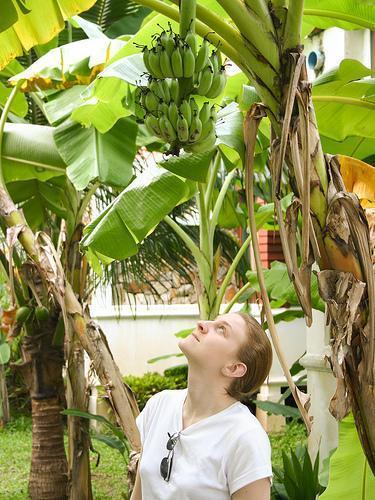How many people are there?
Give a very brief answer. 1. 